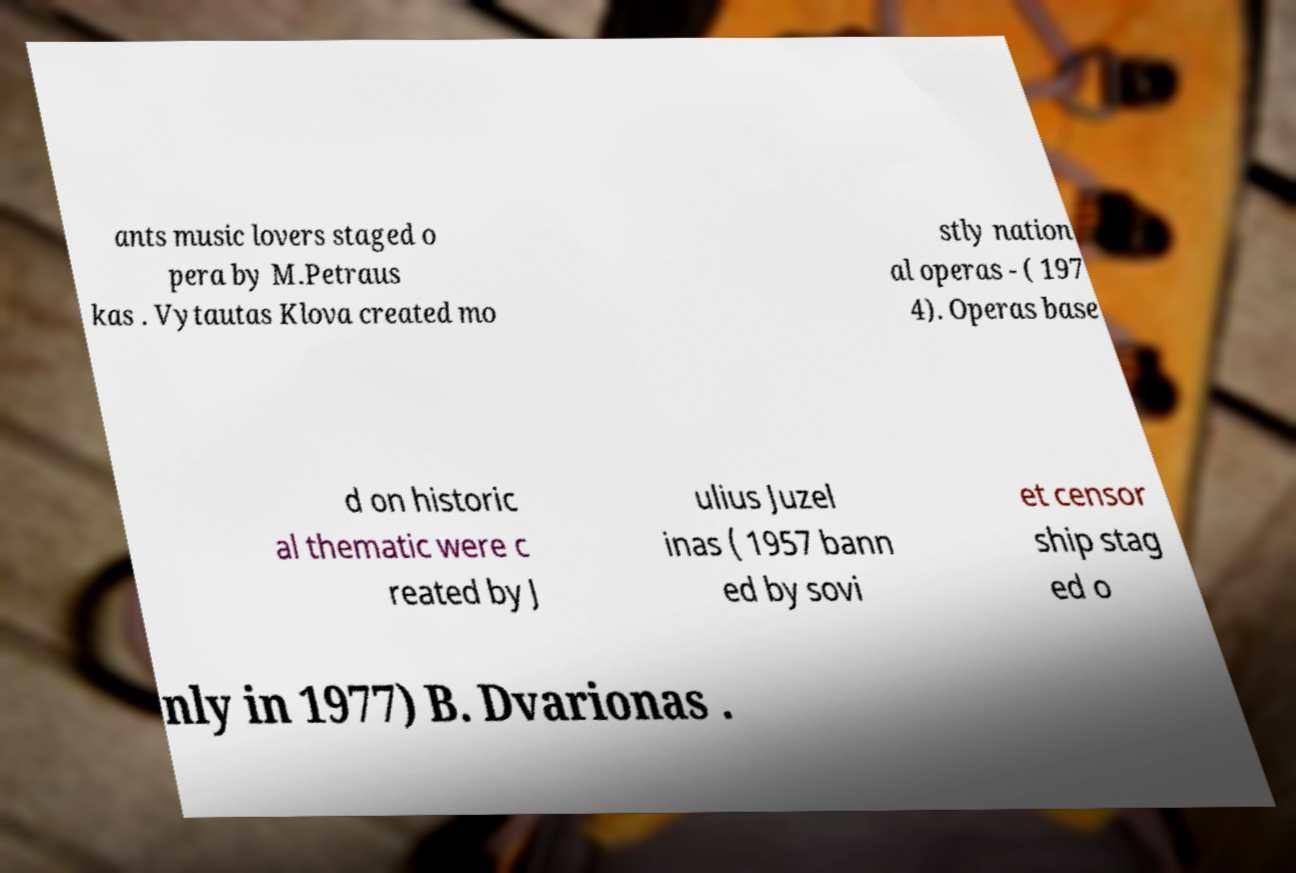What messages or text are displayed in this image? I need them in a readable, typed format. ants music lovers staged o pera by M.Petraus kas . Vytautas Klova created mo stly nation al operas - ( 197 4). Operas base d on historic al thematic were c reated by J ulius Juzel inas ( 1957 bann ed by sovi et censor ship stag ed o nly in 1977) B. Dvarionas . 